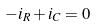<formula> <loc_0><loc_0><loc_500><loc_500>- i _ { R } + i _ { C } = 0</formula> 